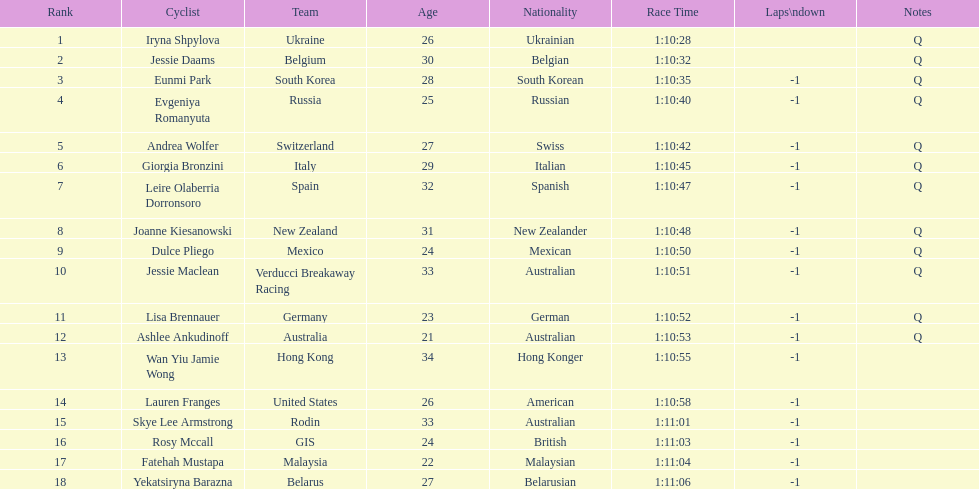Who was the competitor that finished above jessie maclean? Dulce Pliego. 